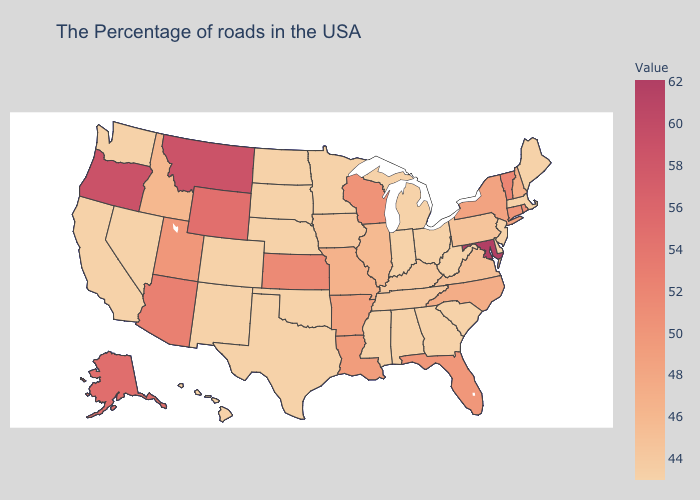Among the states that border Alabama , does Florida have the lowest value?
Short answer required. No. Does the map have missing data?
Keep it brief. No. Among the states that border Missouri , does Tennessee have the lowest value?
Keep it brief. No. Among the states that border Arizona , does Utah have the highest value?
Write a very short answer. Yes. Which states have the lowest value in the USA?
Be succinct. Maine, Massachusetts, New Jersey, Delaware, South Carolina, West Virginia, Ohio, Georgia, Michigan, Indiana, Alabama, Mississippi, Minnesota, Nebraska, Oklahoma, Texas, South Dakota, North Dakota, Colorado, New Mexico, Nevada, California, Washington, Hawaii. 